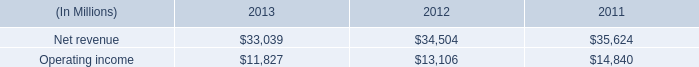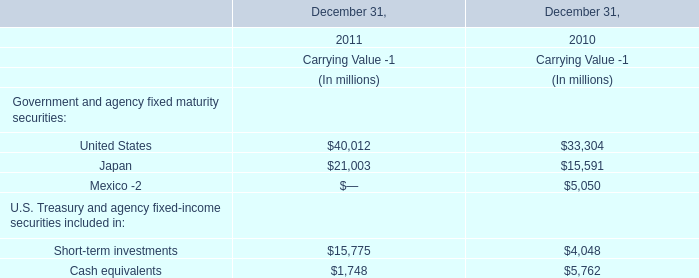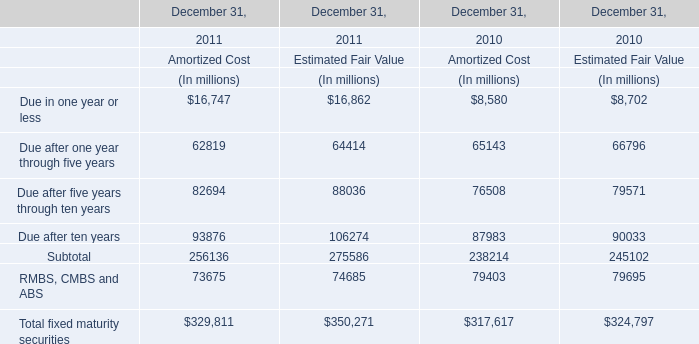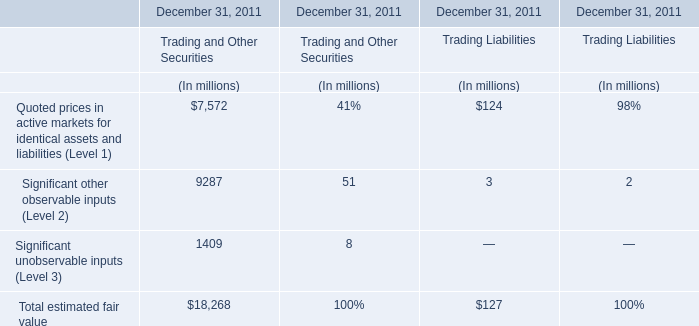In which section the sum of United States has the highest value? 
Answer: 2011. 